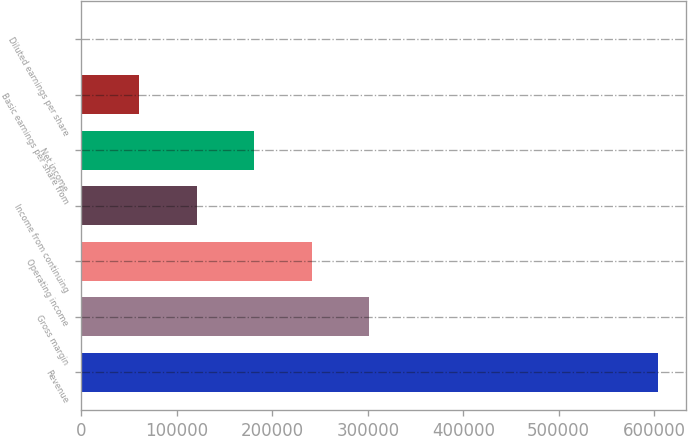<chart> <loc_0><loc_0><loc_500><loc_500><bar_chart><fcel>Revenue<fcel>Gross margin<fcel>Operating income<fcel>Income from continuing<fcel>Net income<fcel>Basic earnings per share from<fcel>Diluted earnings per share<nl><fcel>603516<fcel>301758<fcel>241407<fcel>120703<fcel>181055<fcel>60351.9<fcel>0.36<nl></chart> 